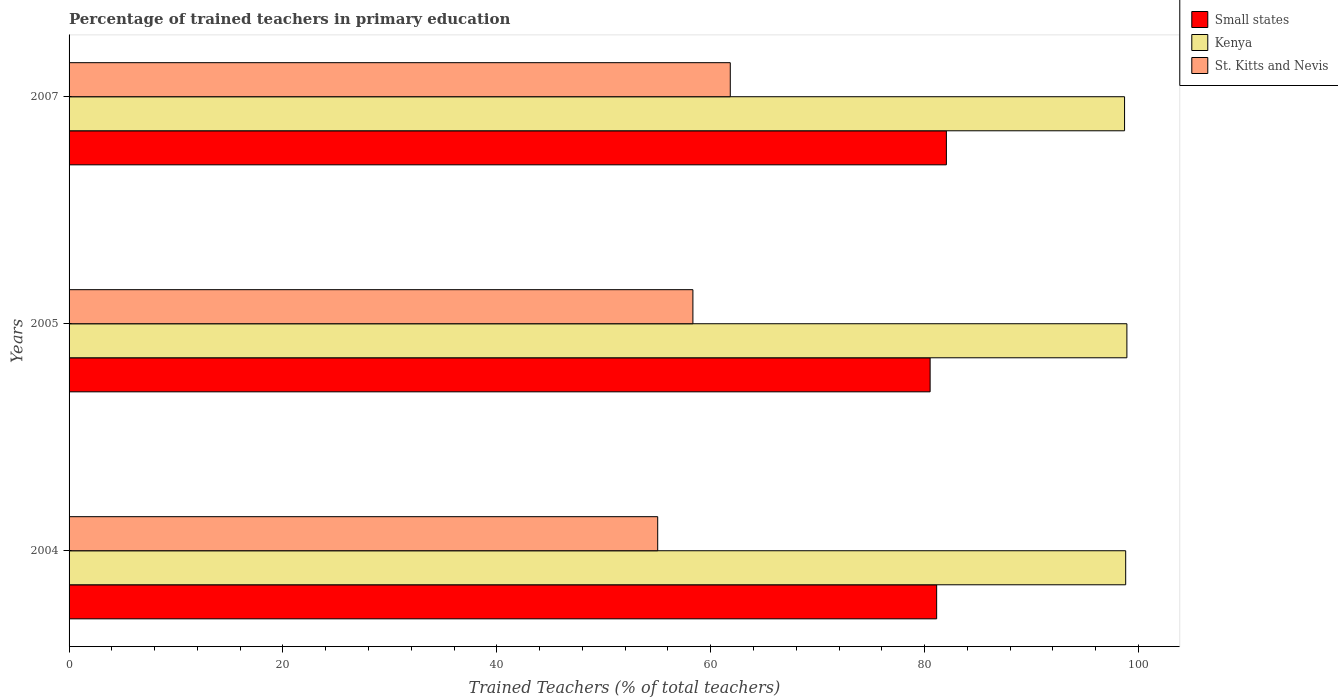How many groups of bars are there?
Ensure brevity in your answer.  3. What is the label of the 1st group of bars from the top?
Provide a succinct answer. 2007. In how many cases, is the number of bars for a given year not equal to the number of legend labels?
Make the answer very short. 0. What is the percentage of trained teachers in St. Kitts and Nevis in 2004?
Your answer should be very brief. 55.04. Across all years, what is the maximum percentage of trained teachers in St. Kitts and Nevis?
Provide a succinct answer. 61.83. Across all years, what is the minimum percentage of trained teachers in Small states?
Keep it short and to the point. 80.51. In which year was the percentage of trained teachers in St. Kitts and Nevis maximum?
Offer a very short reply. 2007. In which year was the percentage of trained teachers in St. Kitts and Nevis minimum?
Offer a terse response. 2004. What is the total percentage of trained teachers in St. Kitts and Nevis in the graph?
Ensure brevity in your answer.  175.2. What is the difference between the percentage of trained teachers in Small states in 2004 and that in 2005?
Your response must be concise. 0.61. What is the difference between the percentage of trained teachers in Kenya in 2004 and the percentage of trained teachers in St. Kitts and Nevis in 2007?
Your response must be concise. 36.97. What is the average percentage of trained teachers in St. Kitts and Nevis per year?
Offer a very short reply. 58.4. In the year 2005, what is the difference between the percentage of trained teachers in St. Kitts and Nevis and percentage of trained teachers in Small states?
Your answer should be very brief. -22.18. What is the ratio of the percentage of trained teachers in Kenya in 2004 to that in 2007?
Your response must be concise. 1. Is the percentage of trained teachers in Small states in 2004 less than that in 2007?
Give a very brief answer. Yes. Is the difference between the percentage of trained teachers in St. Kitts and Nevis in 2004 and 2005 greater than the difference between the percentage of trained teachers in Small states in 2004 and 2005?
Offer a terse response. No. What is the difference between the highest and the second highest percentage of trained teachers in St. Kitts and Nevis?
Your answer should be compact. 3.49. What is the difference between the highest and the lowest percentage of trained teachers in Small states?
Make the answer very short. 1.52. In how many years, is the percentage of trained teachers in Small states greater than the average percentage of trained teachers in Small states taken over all years?
Ensure brevity in your answer.  1. Is the sum of the percentage of trained teachers in Kenya in 2004 and 2005 greater than the maximum percentage of trained teachers in St. Kitts and Nevis across all years?
Offer a terse response. Yes. What does the 3rd bar from the top in 2007 represents?
Ensure brevity in your answer.  Small states. What does the 2nd bar from the bottom in 2005 represents?
Give a very brief answer. Kenya. How many bars are there?
Make the answer very short. 9. What is the difference between two consecutive major ticks on the X-axis?
Provide a short and direct response. 20. Are the values on the major ticks of X-axis written in scientific E-notation?
Offer a very short reply. No. Does the graph contain grids?
Give a very brief answer. No. What is the title of the graph?
Your answer should be compact. Percentage of trained teachers in primary education. Does "Central Europe" appear as one of the legend labels in the graph?
Ensure brevity in your answer.  No. What is the label or title of the X-axis?
Provide a succinct answer. Trained Teachers (% of total teachers). What is the Trained Teachers (% of total teachers) of Small states in 2004?
Ensure brevity in your answer.  81.13. What is the Trained Teachers (% of total teachers) of Kenya in 2004?
Your answer should be compact. 98.8. What is the Trained Teachers (% of total teachers) in St. Kitts and Nevis in 2004?
Make the answer very short. 55.04. What is the Trained Teachers (% of total teachers) of Small states in 2005?
Provide a succinct answer. 80.51. What is the Trained Teachers (% of total teachers) of Kenya in 2005?
Keep it short and to the point. 98.91. What is the Trained Teachers (% of total teachers) in St. Kitts and Nevis in 2005?
Provide a succinct answer. 58.33. What is the Trained Teachers (% of total teachers) in Small states in 2007?
Ensure brevity in your answer.  82.04. What is the Trained Teachers (% of total teachers) in Kenya in 2007?
Give a very brief answer. 98.7. What is the Trained Teachers (% of total teachers) in St. Kitts and Nevis in 2007?
Your answer should be very brief. 61.83. Across all years, what is the maximum Trained Teachers (% of total teachers) in Small states?
Give a very brief answer. 82.04. Across all years, what is the maximum Trained Teachers (% of total teachers) in Kenya?
Make the answer very short. 98.91. Across all years, what is the maximum Trained Teachers (% of total teachers) of St. Kitts and Nevis?
Provide a short and direct response. 61.83. Across all years, what is the minimum Trained Teachers (% of total teachers) in Small states?
Offer a very short reply. 80.51. Across all years, what is the minimum Trained Teachers (% of total teachers) in Kenya?
Make the answer very short. 98.7. Across all years, what is the minimum Trained Teachers (% of total teachers) of St. Kitts and Nevis?
Provide a succinct answer. 55.04. What is the total Trained Teachers (% of total teachers) in Small states in the graph?
Offer a very short reply. 243.68. What is the total Trained Teachers (% of total teachers) of Kenya in the graph?
Make the answer very short. 296.41. What is the total Trained Teachers (% of total teachers) of St. Kitts and Nevis in the graph?
Ensure brevity in your answer.  175.2. What is the difference between the Trained Teachers (% of total teachers) of Small states in 2004 and that in 2005?
Make the answer very short. 0.61. What is the difference between the Trained Teachers (% of total teachers) in Kenya in 2004 and that in 2005?
Give a very brief answer. -0.11. What is the difference between the Trained Teachers (% of total teachers) in St. Kitts and Nevis in 2004 and that in 2005?
Offer a terse response. -3.29. What is the difference between the Trained Teachers (% of total teachers) in Small states in 2004 and that in 2007?
Keep it short and to the point. -0.91. What is the difference between the Trained Teachers (% of total teachers) in Kenya in 2004 and that in 2007?
Offer a terse response. 0.1. What is the difference between the Trained Teachers (% of total teachers) of St. Kitts and Nevis in 2004 and that in 2007?
Make the answer very short. -6.79. What is the difference between the Trained Teachers (% of total teachers) in Small states in 2005 and that in 2007?
Provide a short and direct response. -1.52. What is the difference between the Trained Teachers (% of total teachers) of Kenya in 2005 and that in 2007?
Offer a very short reply. 0.22. What is the difference between the Trained Teachers (% of total teachers) of St. Kitts and Nevis in 2005 and that in 2007?
Keep it short and to the point. -3.49. What is the difference between the Trained Teachers (% of total teachers) of Small states in 2004 and the Trained Teachers (% of total teachers) of Kenya in 2005?
Make the answer very short. -17.79. What is the difference between the Trained Teachers (% of total teachers) in Small states in 2004 and the Trained Teachers (% of total teachers) in St. Kitts and Nevis in 2005?
Provide a short and direct response. 22.79. What is the difference between the Trained Teachers (% of total teachers) in Kenya in 2004 and the Trained Teachers (% of total teachers) in St. Kitts and Nevis in 2005?
Give a very brief answer. 40.47. What is the difference between the Trained Teachers (% of total teachers) of Small states in 2004 and the Trained Teachers (% of total teachers) of Kenya in 2007?
Keep it short and to the point. -17.57. What is the difference between the Trained Teachers (% of total teachers) of Small states in 2004 and the Trained Teachers (% of total teachers) of St. Kitts and Nevis in 2007?
Your answer should be very brief. 19.3. What is the difference between the Trained Teachers (% of total teachers) of Kenya in 2004 and the Trained Teachers (% of total teachers) of St. Kitts and Nevis in 2007?
Your answer should be very brief. 36.97. What is the difference between the Trained Teachers (% of total teachers) of Small states in 2005 and the Trained Teachers (% of total teachers) of Kenya in 2007?
Your answer should be very brief. -18.18. What is the difference between the Trained Teachers (% of total teachers) in Small states in 2005 and the Trained Teachers (% of total teachers) in St. Kitts and Nevis in 2007?
Provide a short and direct response. 18.69. What is the difference between the Trained Teachers (% of total teachers) of Kenya in 2005 and the Trained Teachers (% of total teachers) of St. Kitts and Nevis in 2007?
Your answer should be compact. 37.09. What is the average Trained Teachers (% of total teachers) of Small states per year?
Keep it short and to the point. 81.23. What is the average Trained Teachers (% of total teachers) in Kenya per year?
Make the answer very short. 98.8. What is the average Trained Teachers (% of total teachers) of St. Kitts and Nevis per year?
Your answer should be very brief. 58.4. In the year 2004, what is the difference between the Trained Teachers (% of total teachers) of Small states and Trained Teachers (% of total teachers) of Kenya?
Keep it short and to the point. -17.68. In the year 2004, what is the difference between the Trained Teachers (% of total teachers) in Small states and Trained Teachers (% of total teachers) in St. Kitts and Nevis?
Ensure brevity in your answer.  26.08. In the year 2004, what is the difference between the Trained Teachers (% of total teachers) in Kenya and Trained Teachers (% of total teachers) in St. Kitts and Nevis?
Offer a terse response. 43.76. In the year 2005, what is the difference between the Trained Teachers (% of total teachers) of Small states and Trained Teachers (% of total teachers) of Kenya?
Make the answer very short. -18.4. In the year 2005, what is the difference between the Trained Teachers (% of total teachers) in Small states and Trained Teachers (% of total teachers) in St. Kitts and Nevis?
Ensure brevity in your answer.  22.18. In the year 2005, what is the difference between the Trained Teachers (% of total teachers) in Kenya and Trained Teachers (% of total teachers) in St. Kitts and Nevis?
Provide a short and direct response. 40.58. In the year 2007, what is the difference between the Trained Teachers (% of total teachers) in Small states and Trained Teachers (% of total teachers) in Kenya?
Make the answer very short. -16.66. In the year 2007, what is the difference between the Trained Teachers (% of total teachers) of Small states and Trained Teachers (% of total teachers) of St. Kitts and Nevis?
Provide a succinct answer. 20.21. In the year 2007, what is the difference between the Trained Teachers (% of total teachers) in Kenya and Trained Teachers (% of total teachers) in St. Kitts and Nevis?
Provide a succinct answer. 36.87. What is the ratio of the Trained Teachers (% of total teachers) of Small states in 2004 to that in 2005?
Make the answer very short. 1.01. What is the ratio of the Trained Teachers (% of total teachers) in St. Kitts and Nevis in 2004 to that in 2005?
Keep it short and to the point. 0.94. What is the ratio of the Trained Teachers (% of total teachers) in Small states in 2004 to that in 2007?
Give a very brief answer. 0.99. What is the ratio of the Trained Teachers (% of total teachers) in Kenya in 2004 to that in 2007?
Make the answer very short. 1. What is the ratio of the Trained Teachers (% of total teachers) in St. Kitts and Nevis in 2004 to that in 2007?
Your answer should be very brief. 0.89. What is the ratio of the Trained Teachers (% of total teachers) of Small states in 2005 to that in 2007?
Ensure brevity in your answer.  0.98. What is the ratio of the Trained Teachers (% of total teachers) in Kenya in 2005 to that in 2007?
Ensure brevity in your answer.  1. What is the ratio of the Trained Teachers (% of total teachers) of St. Kitts and Nevis in 2005 to that in 2007?
Give a very brief answer. 0.94. What is the difference between the highest and the second highest Trained Teachers (% of total teachers) in Small states?
Keep it short and to the point. 0.91. What is the difference between the highest and the second highest Trained Teachers (% of total teachers) in Kenya?
Provide a short and direct response. 0.11. What is the difference between the highest and the second highest Trained Teachers (% of total teachers) of St. Kitts and Nevis?
Provide a short and direct response. 3.49. What is the difference between the highest and the lowest Trained Teachers (% of total teachers) in Small states?
Provide a short and direct response. 1.52. What is the difference between the highest and the lowest Trained Teachers (% of total teachers) in Kenya?
Ensure brevity in your answer.  0.22. What is the difference between the highest and the lowest Trained Teachers (% of total teachers) of St. Kitts and Nevis?
Your response must be concise. 6.79. 